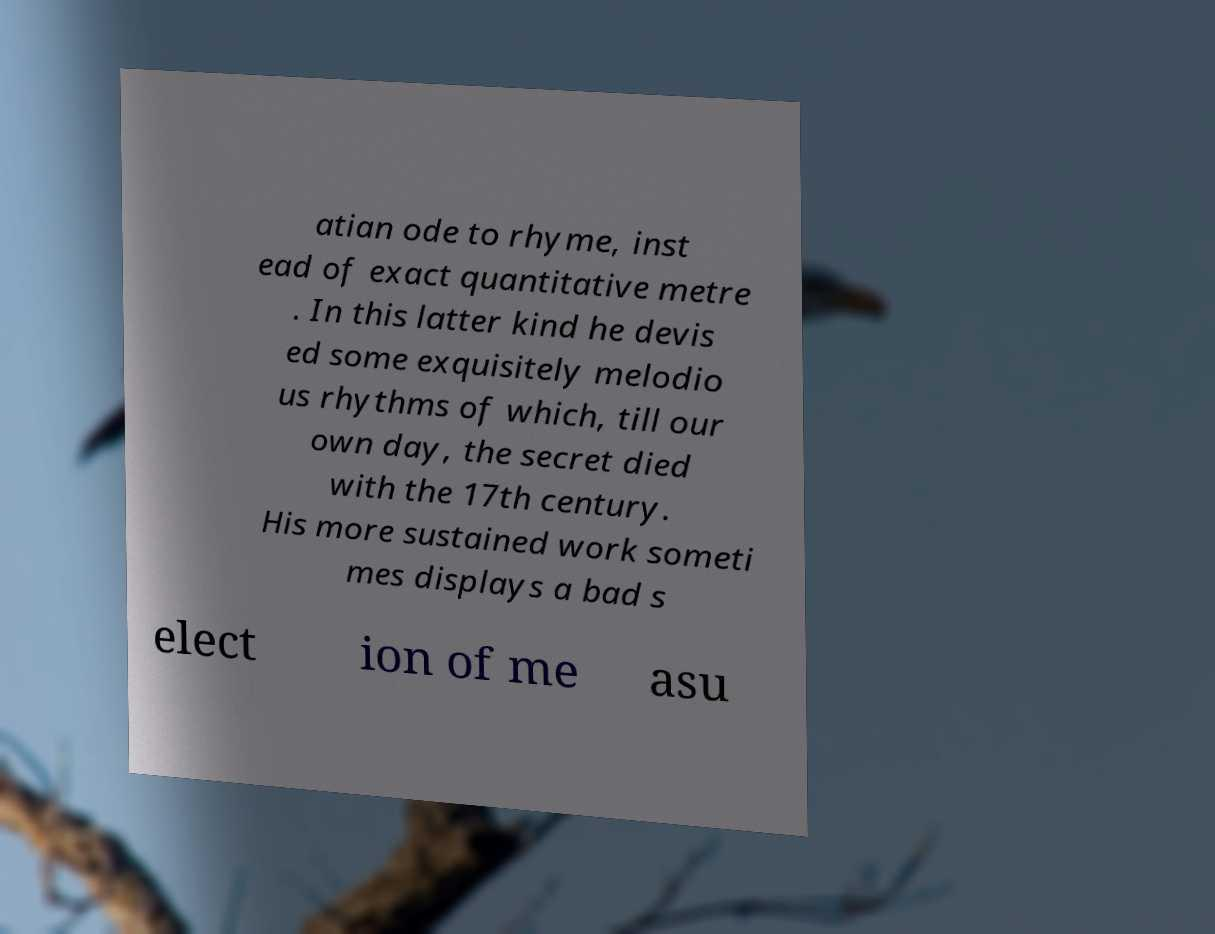Could you assist in decoding the text presented in this image and type it out clearly? atian ode to rhyme, inst ead of exact quantitative metre . In this latter kind he devis ed some exquisitely melodio us rhythms of which, till our own day, the secret died with the 17th century. His more sustained work someti mes displays a bad s elect ion of me asu 